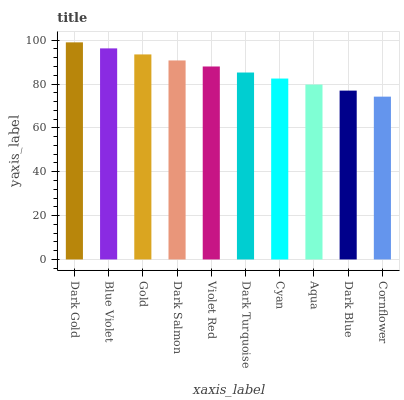Is Cornflower the minimum?
Answer yes or no. Yes. Is Dark Gold the maximum?
Answer yes or no. Yes. Is Blue Violet the minimum?
Answer yes or no. No. Is Blue Violet the maximum?
Answer yes or no. No. Is Dark Gold greater than Blue Violet?
Answer yes or no. Yes. Is Blue Violet less than Dark Gold?
Answer yes or no. Yes. Is Blue Violet greater than Dark Gold?
Answer yes or no. No. Is Dark Gold less than Blue Violet?
Answer yes or no. No. Is Violet Red the high median?
Answer yes or no. Yes. Is Dark Turquoise the low median?
Answer yes or no. Yes. Is Blue Violet the high median?
Answer yes or no. No. Is Violet Red the low median?
Answer yes or no. No. 